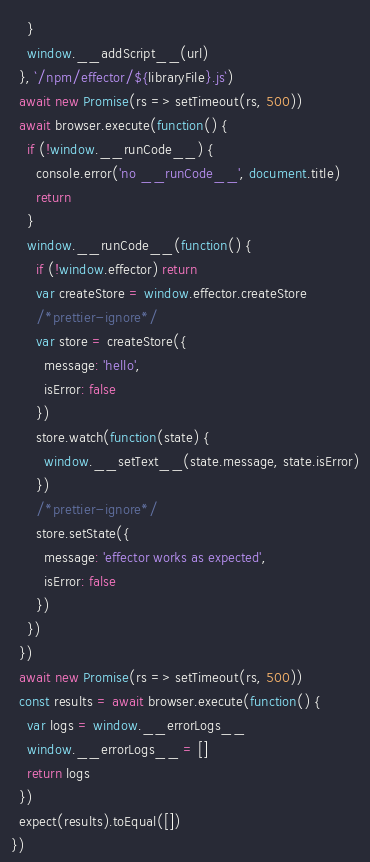<code> <loc_0><loc_0><loc_500><loc_500><_JavaScript_>    }
    window.__addScript__(url)
  }, `/npm/effector/${libraryFile}.js`)
  await new Promise(rs => setTimeout(rs, 500))
  await browser.execute(function() {
    if (!window.__runCode__) {
      console.error('no __runCode__', document.title)
      return
    }
    window.__runCode__(function() {
      if (!window.effector) return
      var createStore = window.effector.createStore
      /*prettier-ignore*/
      var store = createStore({
        message: 'hello',
        isError: false
      })
      store.watch(function(state) {
        window.__setText__(state.message, state.isError)
      })
      /*prettier-ignore*/
      store.setState({
        message: 'effector works as expected',
        isError: false
      })
    })
  })
  await new Promise(rs => setTimeout(rs, 500))
  const results = await browser.execute(function() {
    var logs = window.__errorLogs__
    window.__errorLogs__ = []
    return logs
  })
  expect(results).toEqual([])
})
</code> 